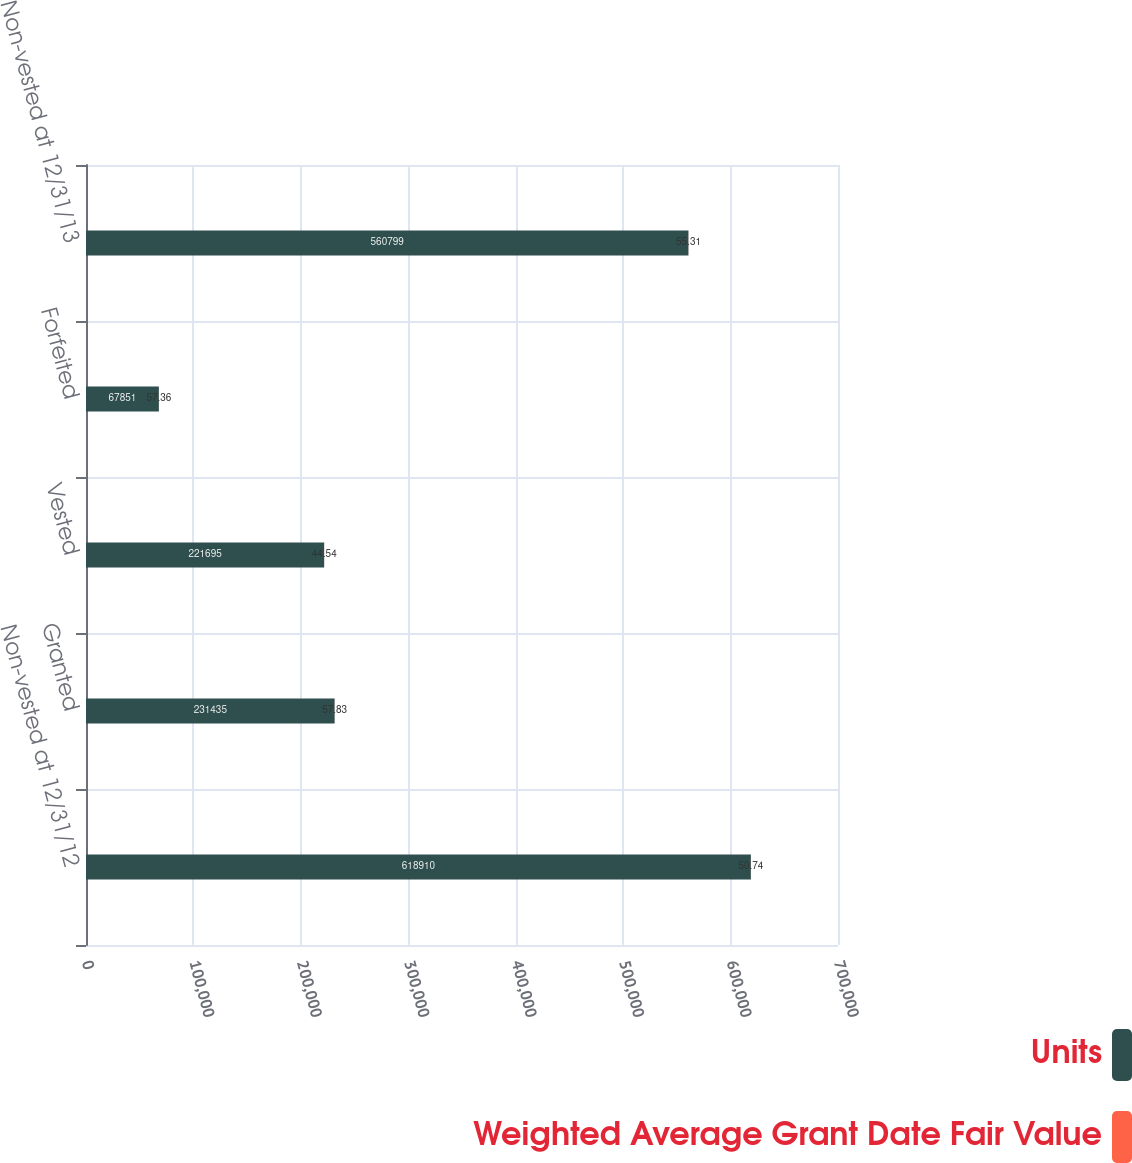Convert chart. <chart><loc_0><loc_0><loc_500><loc_500><stacked_bar_chart><ecel><fcel>Non-vested at 12/31/12<fcel>Granted<fcel>Vested<fcel>Forfeited<fcel>Non-vested at 12/31/13<nl><fcel>Units<fcel>618910<fcel>231435<fcel>221695<fcel>67851<fcel>560799<nl><fcel>Weighted Average Grant Date Fair Value<fcel>50.74<fcel>57.83<fcel>44.54<fcel>57.36<fcel>55.31<nl></chart> 